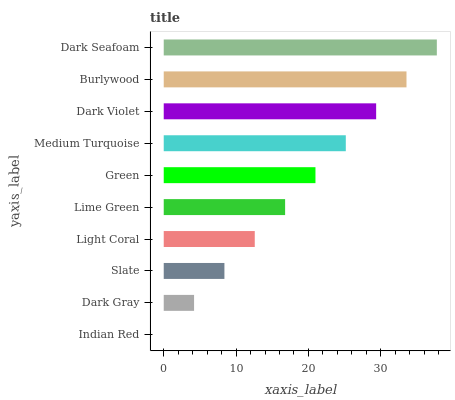Is Indian Red the minimum?
Answer yes or no. Yes. Is Dark Seafoam the maximum?
Answer yes or no. Yes. Is Dark Gray the minimum?
Answer yes or no. No. Is Dark Gray the maximum?
Answer yes or no. No. Is Dark Gray greater than Indian Red?
Answer yes or no. Yes. Is Indian Red less than Dark Gray?
Answer yes or no. Yes. Is Indian Red greater than Dark Gray?
Answer yes or no. No. Is Dark Gray less than Indian Red?
Answer yes or no. No. Is Green the high median?
Answer yes or no. Yes. Is Lime Green the low median?
Answer yes or no. Yes. Is Light Coral the high median?
Answer yes or no. No. Is Dark Gray the low median?
Answer yes or no. No. 